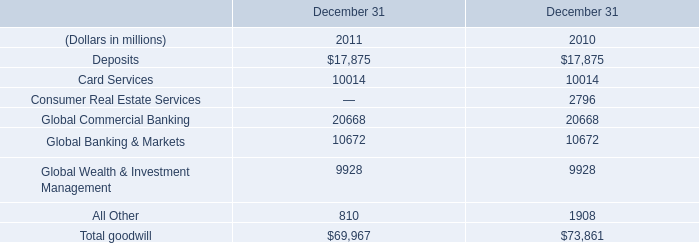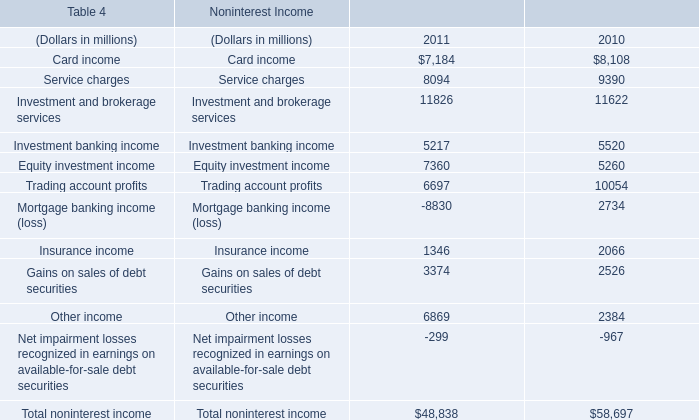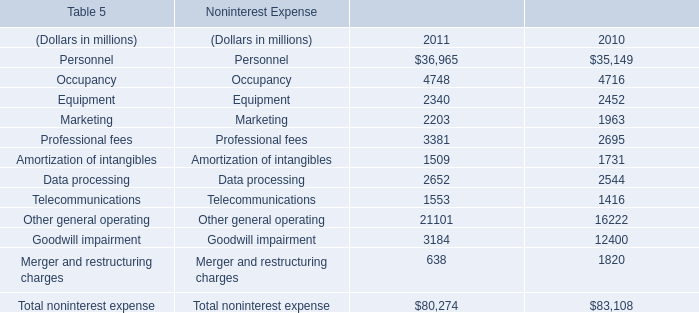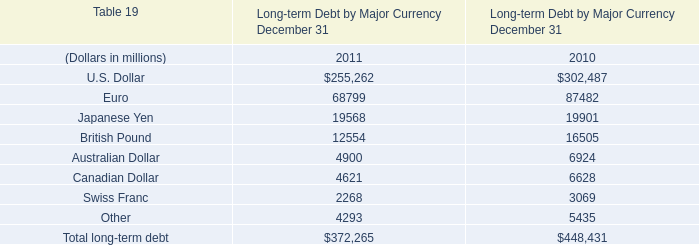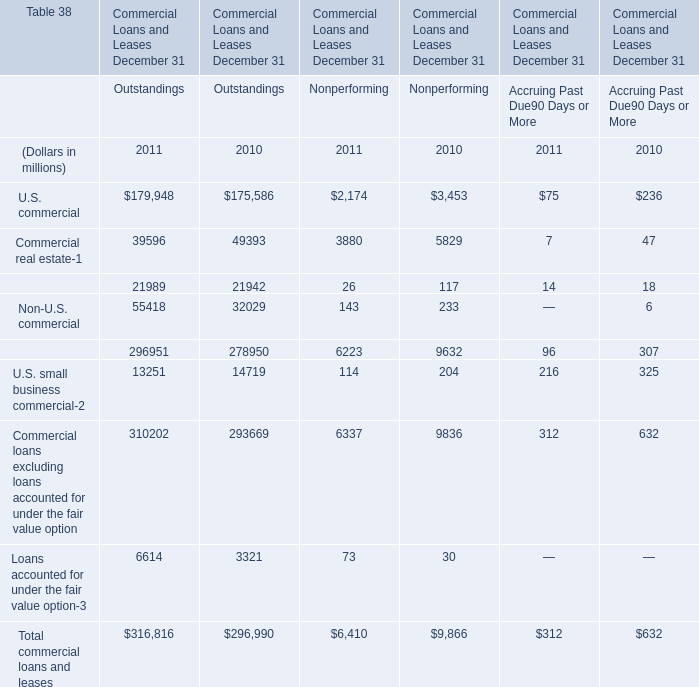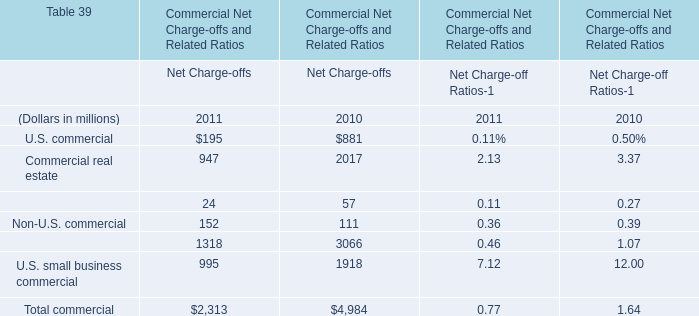What's the sum of Investment banking income of Noninterest Income 2010, Marketing of Noninterest Expense 2011, and Goodwill impairment of Noninterest Expense 2011 ? 
Computations: ((5520.0 + 2203.0) + 3184.0)
Answer: 10907.0. 